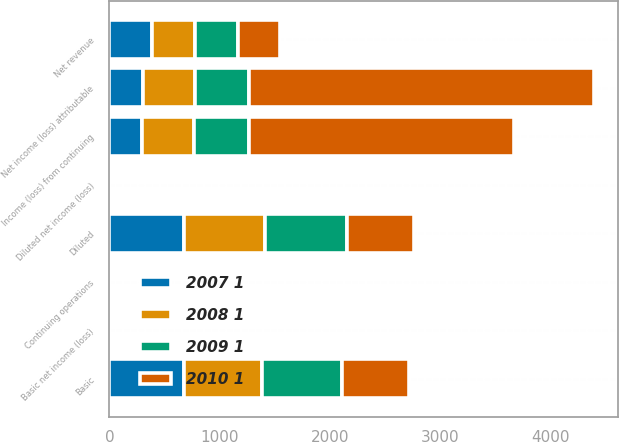Convert chart. <chart><loc_0><loc_0><loc_500><loc_500><stacked_bar_chart><ecel><fcel>Net revenue<fcel>Income (loss) from continuing<fcel>Net income (loss) attributable<fcel>Continuing operations<fcel>Basic net income (loss)<fcel>Diluted net income (loss)<fcel>Basic<fcel>Diluted<nl><fcel>2009 1<fcel>387.5<fcel>495<fcel>491<fcel>0.68<fcel>0.68<fcel>0.66<fcel>727<fcel>742<nl><fcel>2008 1<fcel>387.5<fcel>471<fcel>471<fcel>0.66<fcel>0.66<fcel>0.64<fcel>711<fcel>733<nl><fcel>2007 1<fcel>387.5<fcel>296<fcel>304<fcel>0.46<fcel>0.46<fcel>0.45<fcel>673<fcel>678<nl><fcel>2010 1<fcel>387.5<fcel>2412<fcel>3129<fcel>4.03<fcel>5.15<fcel>5.15<fcel>607<fcel>607<nl></chart> 